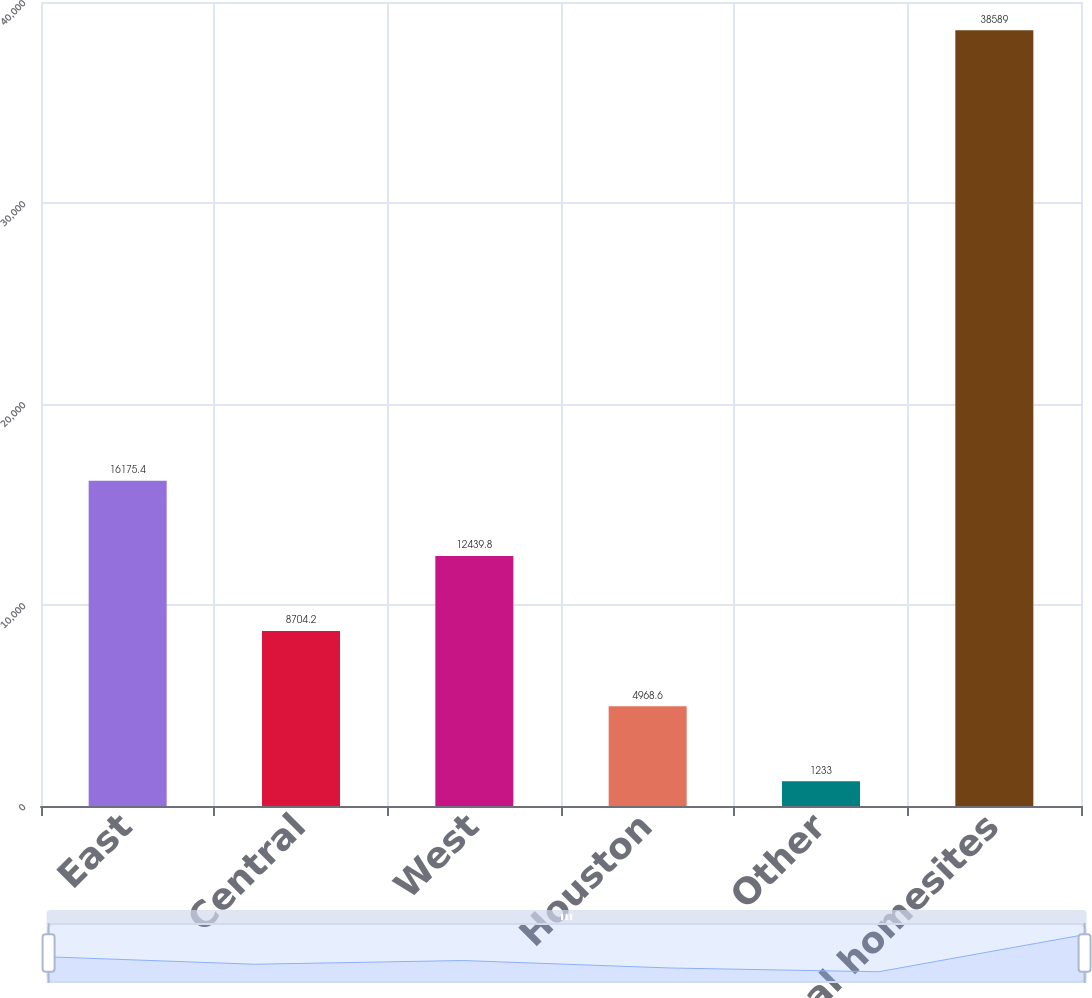Convert chart. <chart><loc_0><loc_0><loc_500><loc_500><bar_chart><fcel>East<fcel>Central<fcel>West<fcel>Houston<fcel>Other<fcel>Total homesites<nl><fcel>16175.4<fcel>8704.2<fcel>12439.8<fcel>4968.6<fcel>1233<fcel>38589<nl></chart> 